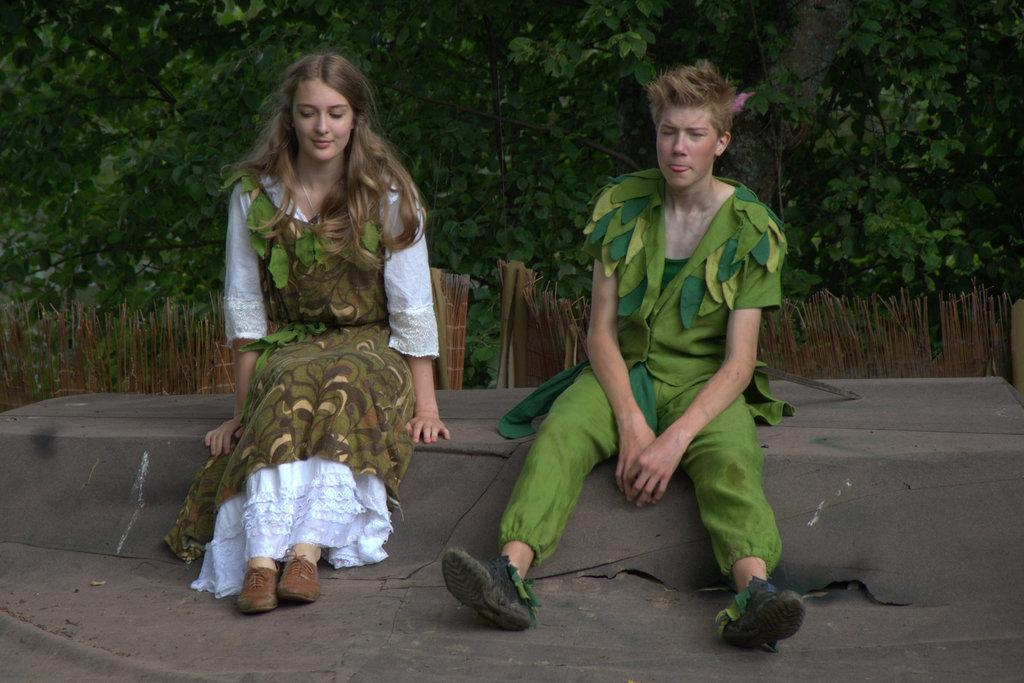How many people are in the image? There are two people in the image, a man and a woman. What is the woman doing in the image? The woman is smiling in the image. What is the man wearing in the image? The man is wearing a green dress in the image. What can be seen in the background of the image? There are trees in the background of the image. What type of insect is crawling on the man's mouth in the image? There is no insect present on the man's mouth in the image. 